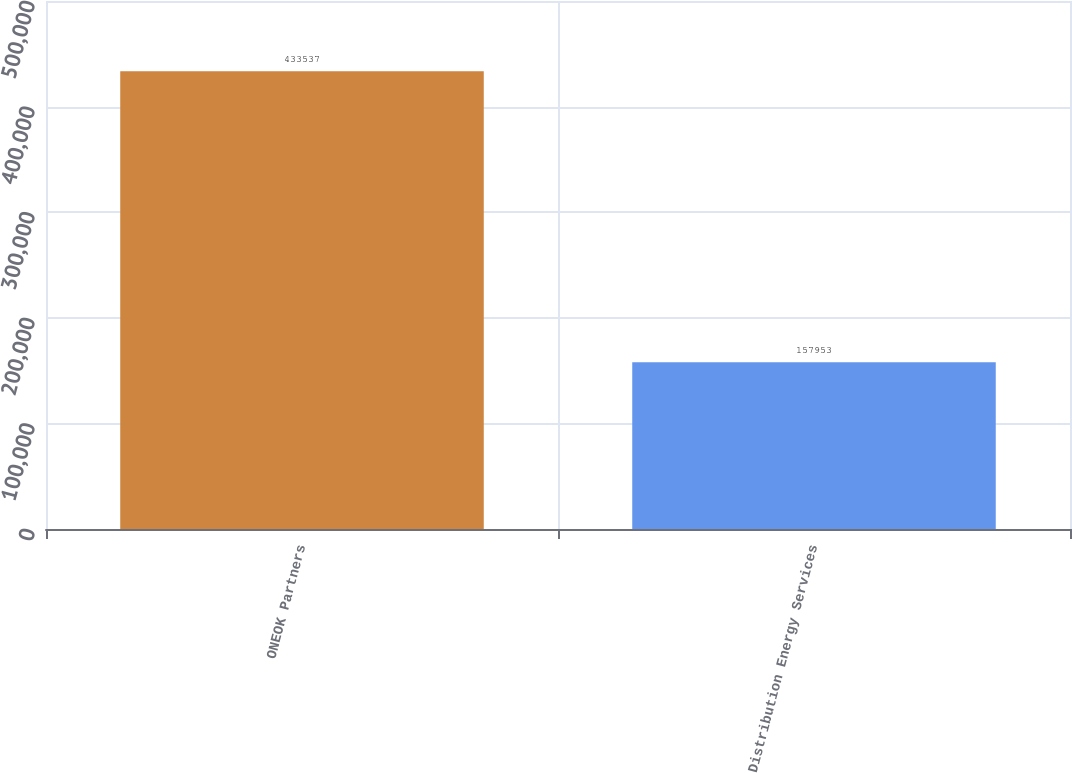<chart> <loc_0><loc_0><loc_500><loc_500><bar_chart><fcel>ONEOK Partners<fcel>Distribution Energy Services<nl><fcel>433537<fcel>157953<nl></chart> 